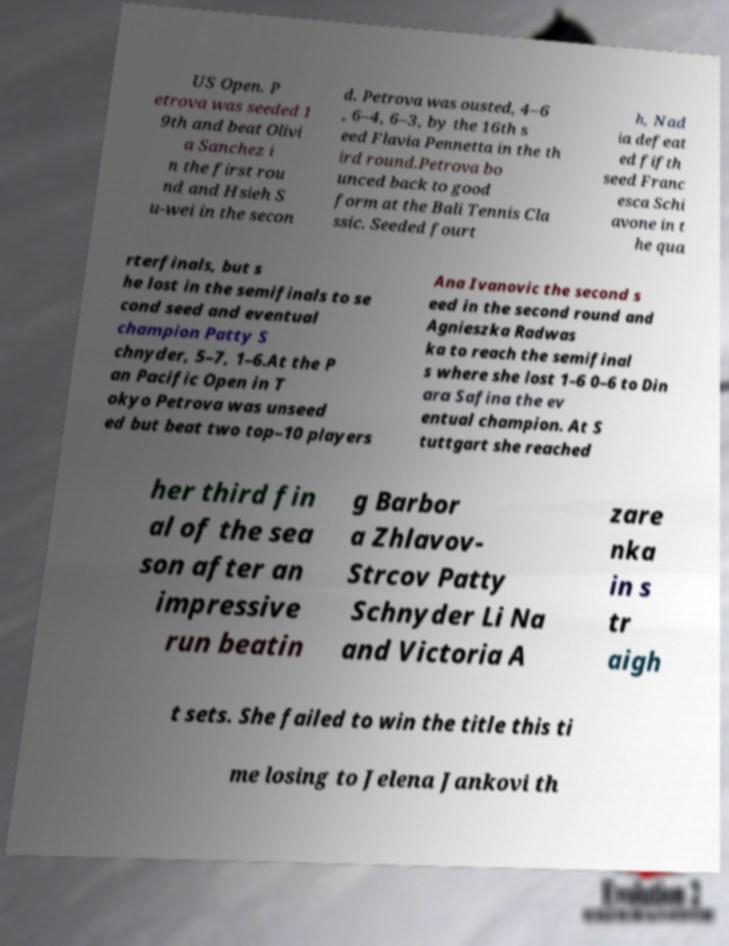Could you assist in decoding the text presented in this image and type it out clearly? US Open. P etrova was seeded 1 9th and beat Olivi a Sanchez i n the first rou nd and Hsieh S u-wei in the secon d. Petrova was ousted, 4–6 , 6–4, 6–3, by the 16th s eed Flavia Pennetta in the th ird round.Petrova bo unced back to good form at the Bali Tennis Cla ssic. Seeded fourt h, Nad ia defeat ed fifth seed Franc esca Schi avone in t he qua rterfinals, but s he lost in the semifinals to se cond seed and eventual champion Patty S chnyder, 5–7, 1–6.At the P an Pacific Open in T okyo Petrova was unseed ed but beat two top–10 players Ana Ivanovic the second s eed in the second round and Agnieszka Radwas ka to reach the semifinal s where she lost 1–6 0–6 to Din ara Safina the ev entual champion. At S tuttgart she reached her third fin al of the sea son after an impressive run beatin g Barbor a Zhlavov- Strcov Patty Schnyder Li Na and Victoria A zare nka in s tr aigh t sets. She failed to win the title this ti me losing to Jelena Jankovi th 